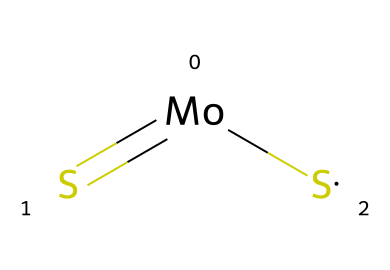What is the total number of atoms in the molecular formula of this compound? The SMILES representation [Mo](=[S])[S] indicates that there is one molybdenum atom (Mo) and two sulfur atoms (S). Adding these gives a total of three atoms.
Answer: three How many sulfur atoms are present in this chemical? In the SMILES notation, there are two 'S' symbols, indicating two sulfur atoms are part of the compound.
Answer: two What is the oxidation state of molybdenum in this compound? Molybdenum (Mo) has an oxidation state of +4 based on its bonding with two sulfur atoms (each typically has an oxidation state of -2), thus requiring positive charge to balance.
Answer: +4 Which type of bond connects molybdenum and sulfur in this compound? The notation [Mo](=[S]) indicates a double bond between molybdenum and one sulfur atom. Thus, the bond type is categorized as a double bond.
Answer: double bond Is this compound considered a solid lubricant? Molybdenum disulfide (MoS2) is widely recognized for its lubricating properties and is used as a solid lubricant.
Answer: yes What physical property of MoS2 contributes to its function as a lubricant? Molybdenum disulfide has low friction characteristics due to its layered structure, which allows easy sliding between layers.
Answer: low friction 